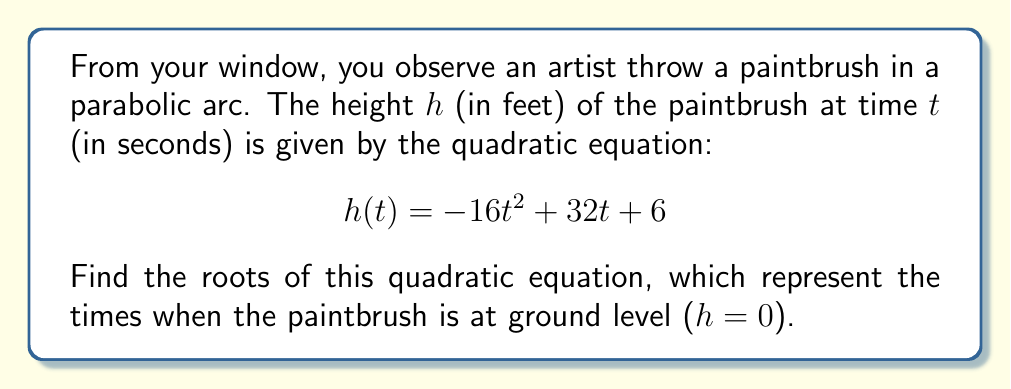Show me your answer to this math problem. To find the roots of the quadratic equation, we need to solve:

$$ -16t^2 + 32t + 6 = 0 $$

Let's solve this step-by-step using the quadratic formula: $t = \frac{-b \pm \sqrt{b^2 - 4ac}}{2a}$

1) Identify $a$, $b$, and $c$:
   $a = -16$, $b = 32$, $c = 6$

2) Substitute these values into the quadratic formula:

   $t = \frac{-32 \pm \sqrt{32^2 - 4(-16)(6)}}{2(-16)}$

3) Simplify under the square root:
   
   $t = \frac{-32 \pm \sqrt{1024 + 384}}{-32} = \frac{-32 \pm \sqrt{1408}}{-32}$

4) Simplify $\sqrt{1408}$:
   
   $\sqrt{1408} = \sqrt{16 \times 88} = 4\sqrt{22}$

5) Substitute back:

   $t = \frac{-32 \pm 4\sqrt{22}}{-32} = \frac{32 \mp 4\sqrt{22}}{32} = 1 \mp \frac{\sqrt{22}}{8}$

6) Therefore, the two roots are:

   $t_1 = 1 + \frac{\sqrt{22}}{8}$ and $t_2 = 1 - \frac{\sqrt{22}}{8}$
Answer: $t_1 = 1 + \frac{\sqrt{22}}{8}$, $t_2 = 1 - \frac{\sqrt{22}}{8}$ 